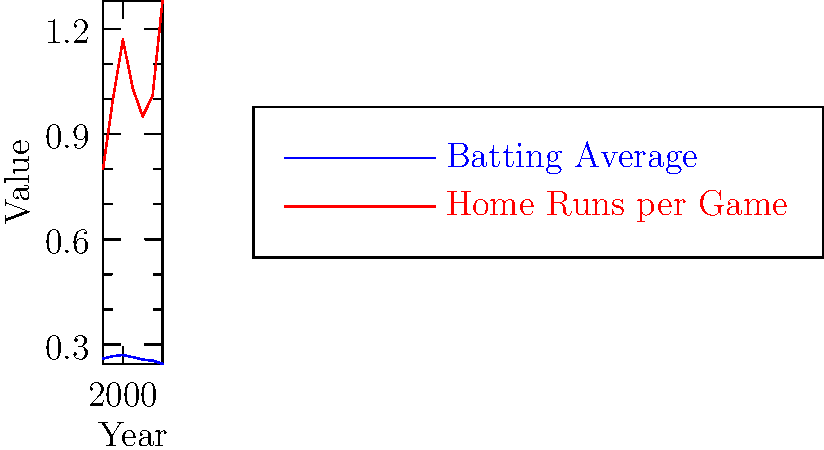During Johnny Doskow's career as a broadcaster from 1990 to 2020, what contrasting trends can be observed in batting averages and home runs per game in Major League Baseball? To answer this question, we need to analyze the trends in the two statistics shown in the graph:

1. Batting Average (blue line):
   - Started at about 0.260 in 1990
   - Peaked around 2000 at 0.270
   - Steadily declined after 2000
   - Reached its lowest point of 0.245 in 2020

2. Home Runs per Game (red line):
   - Started at about 0.8 in 1990
   - Increased to 1.17 by 2000
   - Fluctuated between 2000 and 2015
   - Sharply increased from 2015 to 2020, reaching 1.28

The contrasting trends are:
1. Batting averages have generally decreased since 2000.
2. Home runs per game have increased overall, with a sharp rise in recent years.

These trends suggest that while players are hitting for more power (more home runs), they are making less contact overall (lower batting averages).
Answer: Declining batting averages, increasing home runs 